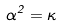Convert formula to latex. <formula><loc_0><loc_0><loc_500><loc_500>\alpha ^ { 2 } = \kappa</formula> 